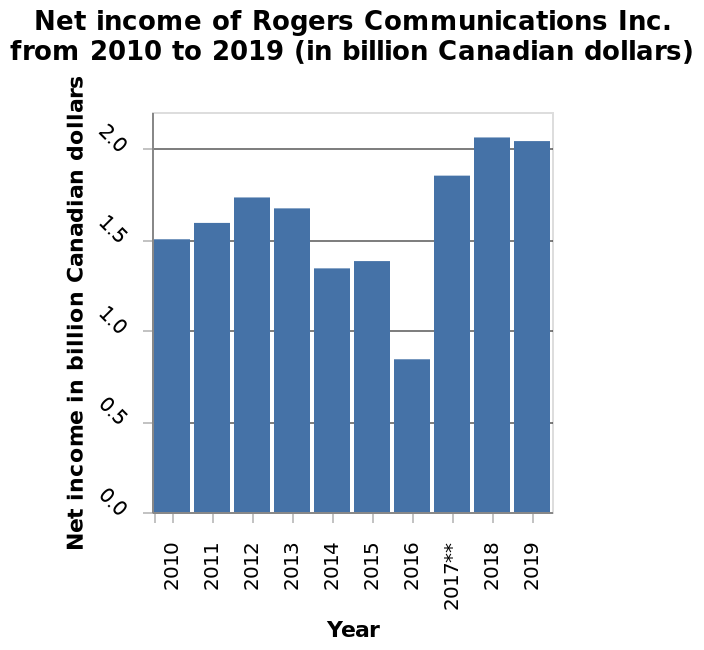<image>
Offer a thorough analysis of the image. the net income of Rogers communications between 2010 and 2019 has both positive and negative trends which seem to last for 3 year periods, in 2017 rogers communications had a gigantic increase in net income, doubling from its previous year of 2016. 